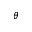Convert formula to latex. <formula><loc_0><loc_0><loc_500><loc_500>\theta</formula> 